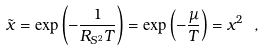<formula> <loc_0><loc_0><loc_500><loc_500>\tilde { x } = \exp \left ( - \frac { 1 } { R _ { S ^ { 2 } } T } \right ) = \exp \left ( - \frac { \mu } { T } \right ) = x ^ { 2 } \ ,</formula> 